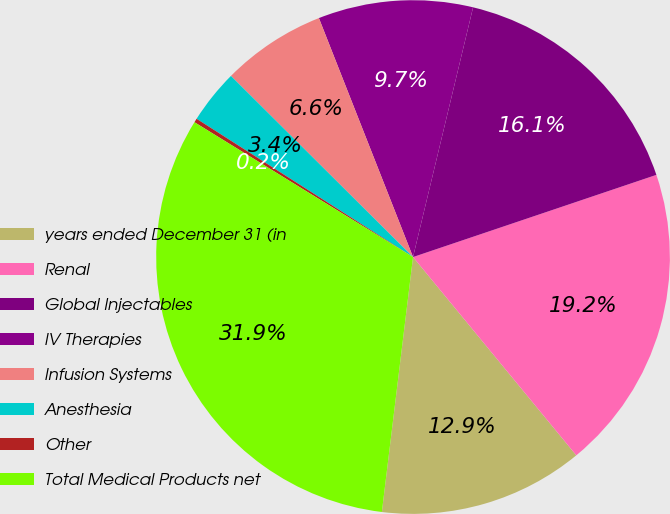Convert chart to OTSL. <chart><loc_0><loc_0><loc_500><loc_500><pie_chart><fcel>years ended December 31 (in<fcel>Renal<fcel>Global Injectables<fcel>IV Therapies<fcel>Infusion Systems<fcel>Anesthesia<fcel>Other<fcel>Total Medical Products net<nl><fcel>12.9%<fcel>19.22%<fcel>16.06%<fcel>9.73%<fcel>6.57%<fcel>3.41%<fcel>0.25%<fcel>31.86%<nl></chart> 